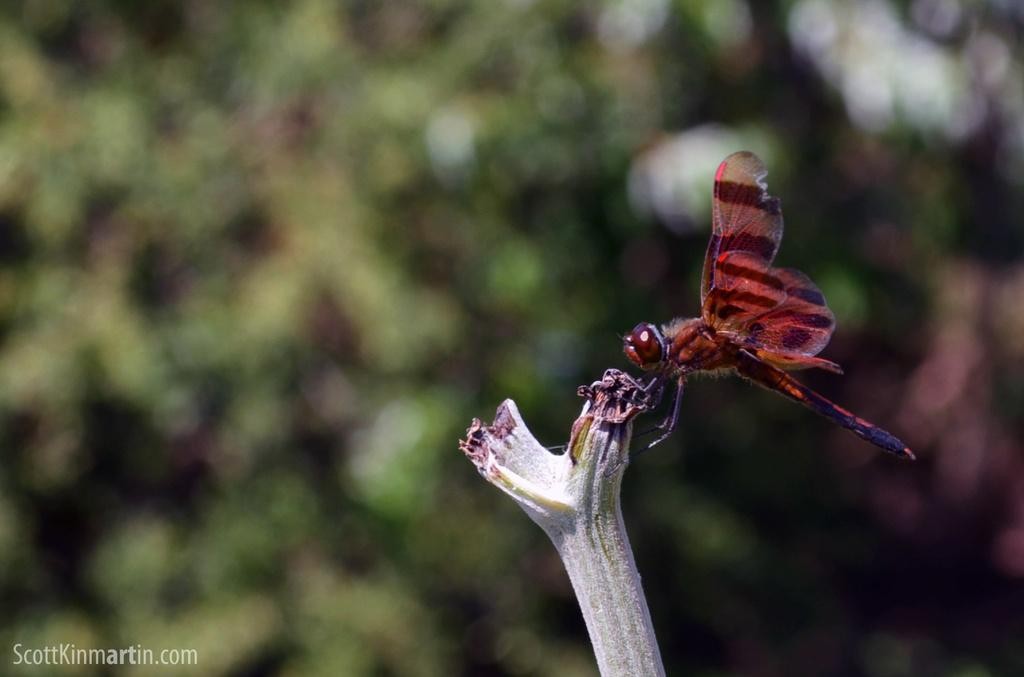What is on the branch of the plant in the image? There is an insect on the branch of a plant in the image. What can be seen in the bottom left corner of the image? There is a watermark in the bottom left of the image. How would you describe the background of the image? The background of the image is blurred. Can you hear the van driving by in the image? There is no van present in the image, so it is not possible to hear it driving by. 